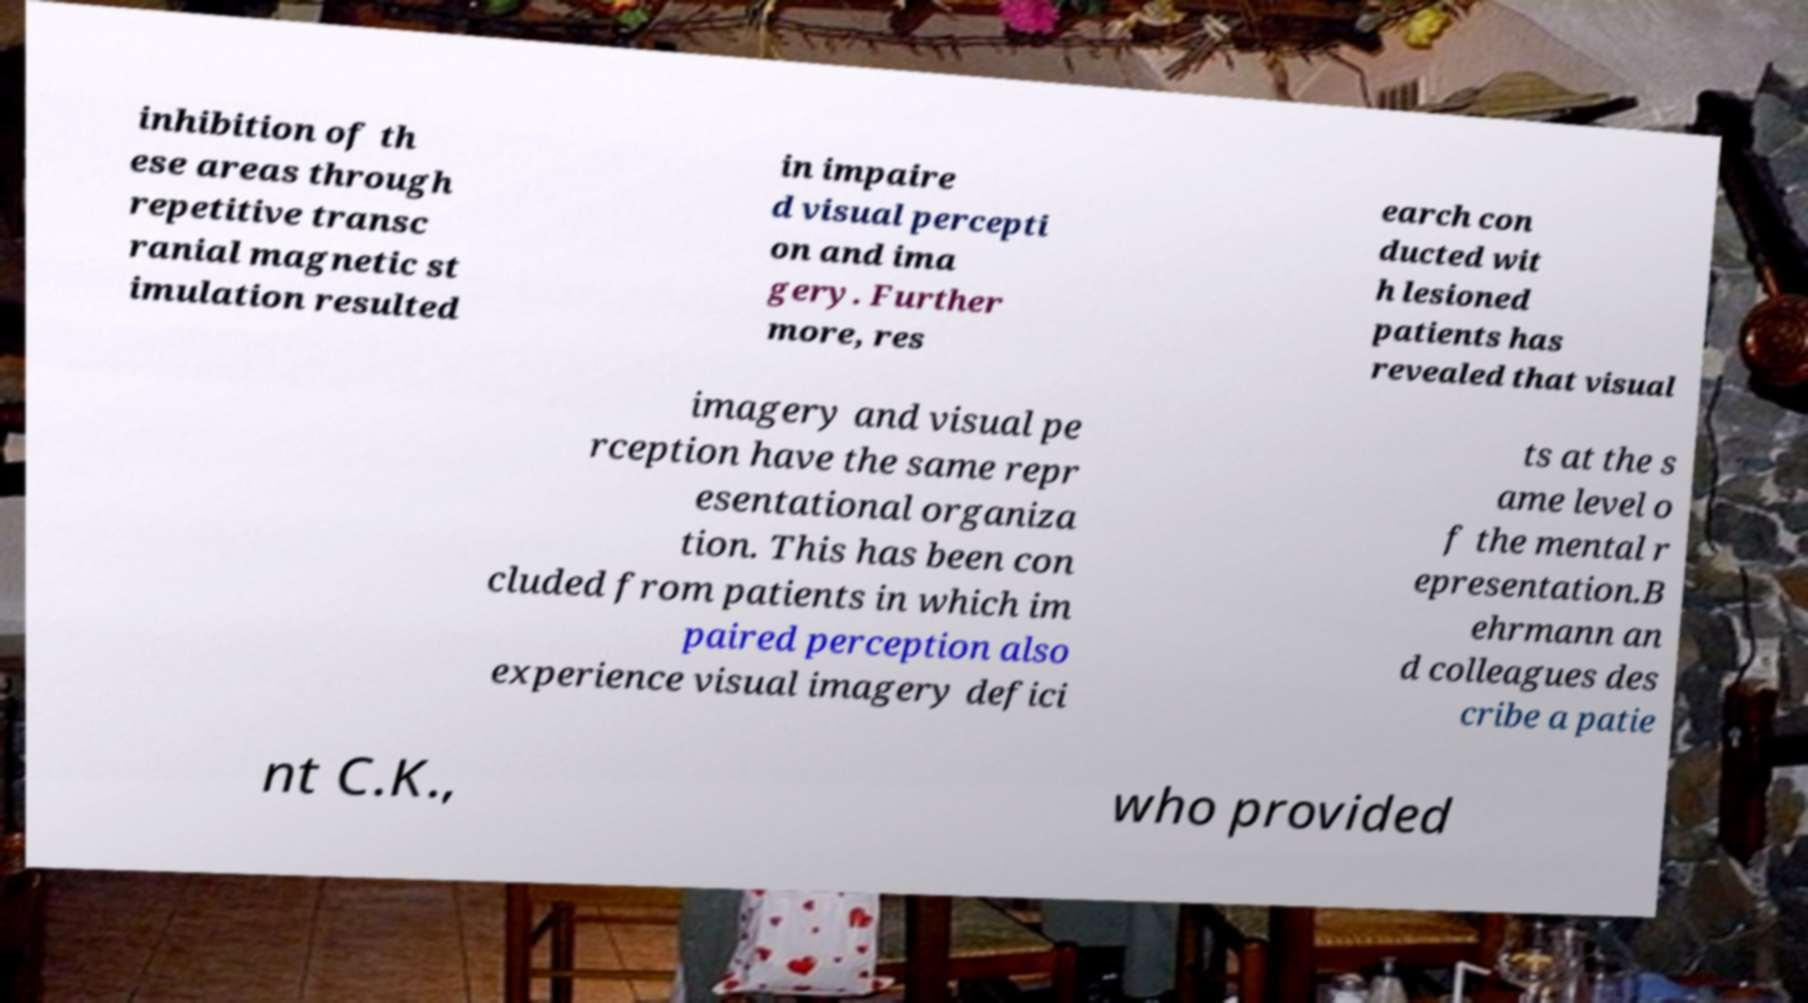For documentation purposes, I need the text within this image transcribed. Could you provide that? inhibition of th ese areas through repetitive transc ranial magnetic st imulation resulted in impaire d visual percepti on and ima gery. Further more, res earch con ducted wit h lesioned patients has revealed that visual imagery and visual pe rception have the same repr esentational organiza tion. This has been con cluded from patients in which im paired perception also experience visual imagery defici ts at the s ame level o f the mental r epresentation.B ehrmann an d colleagues des cribe a patie nt C.K., who provided 